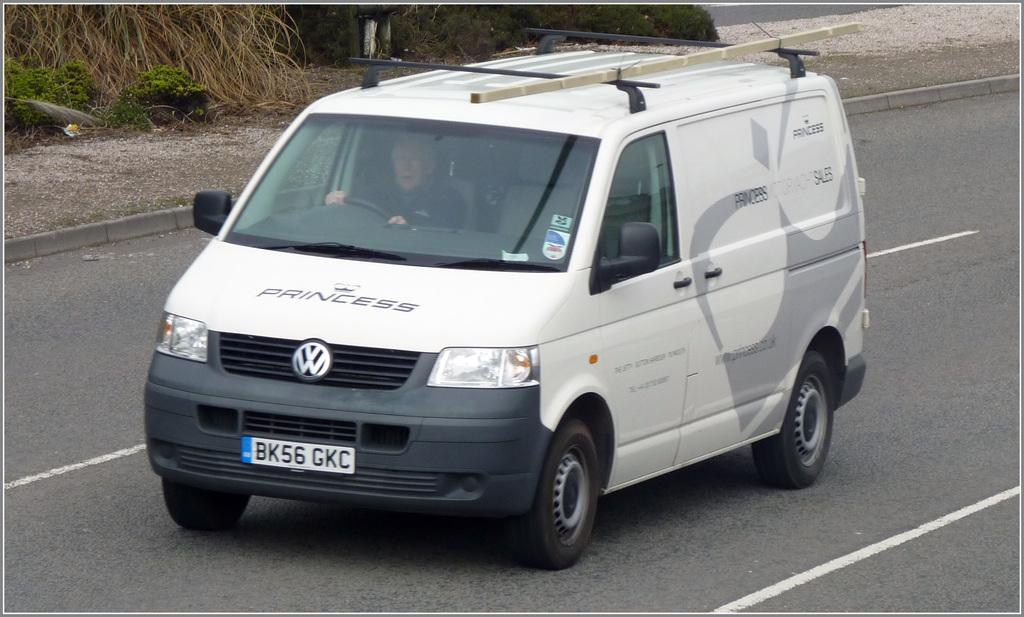<image>
Share a concise interpretation of the image provided. A white Volkswagon van with the word "Princess" written across the hood. 